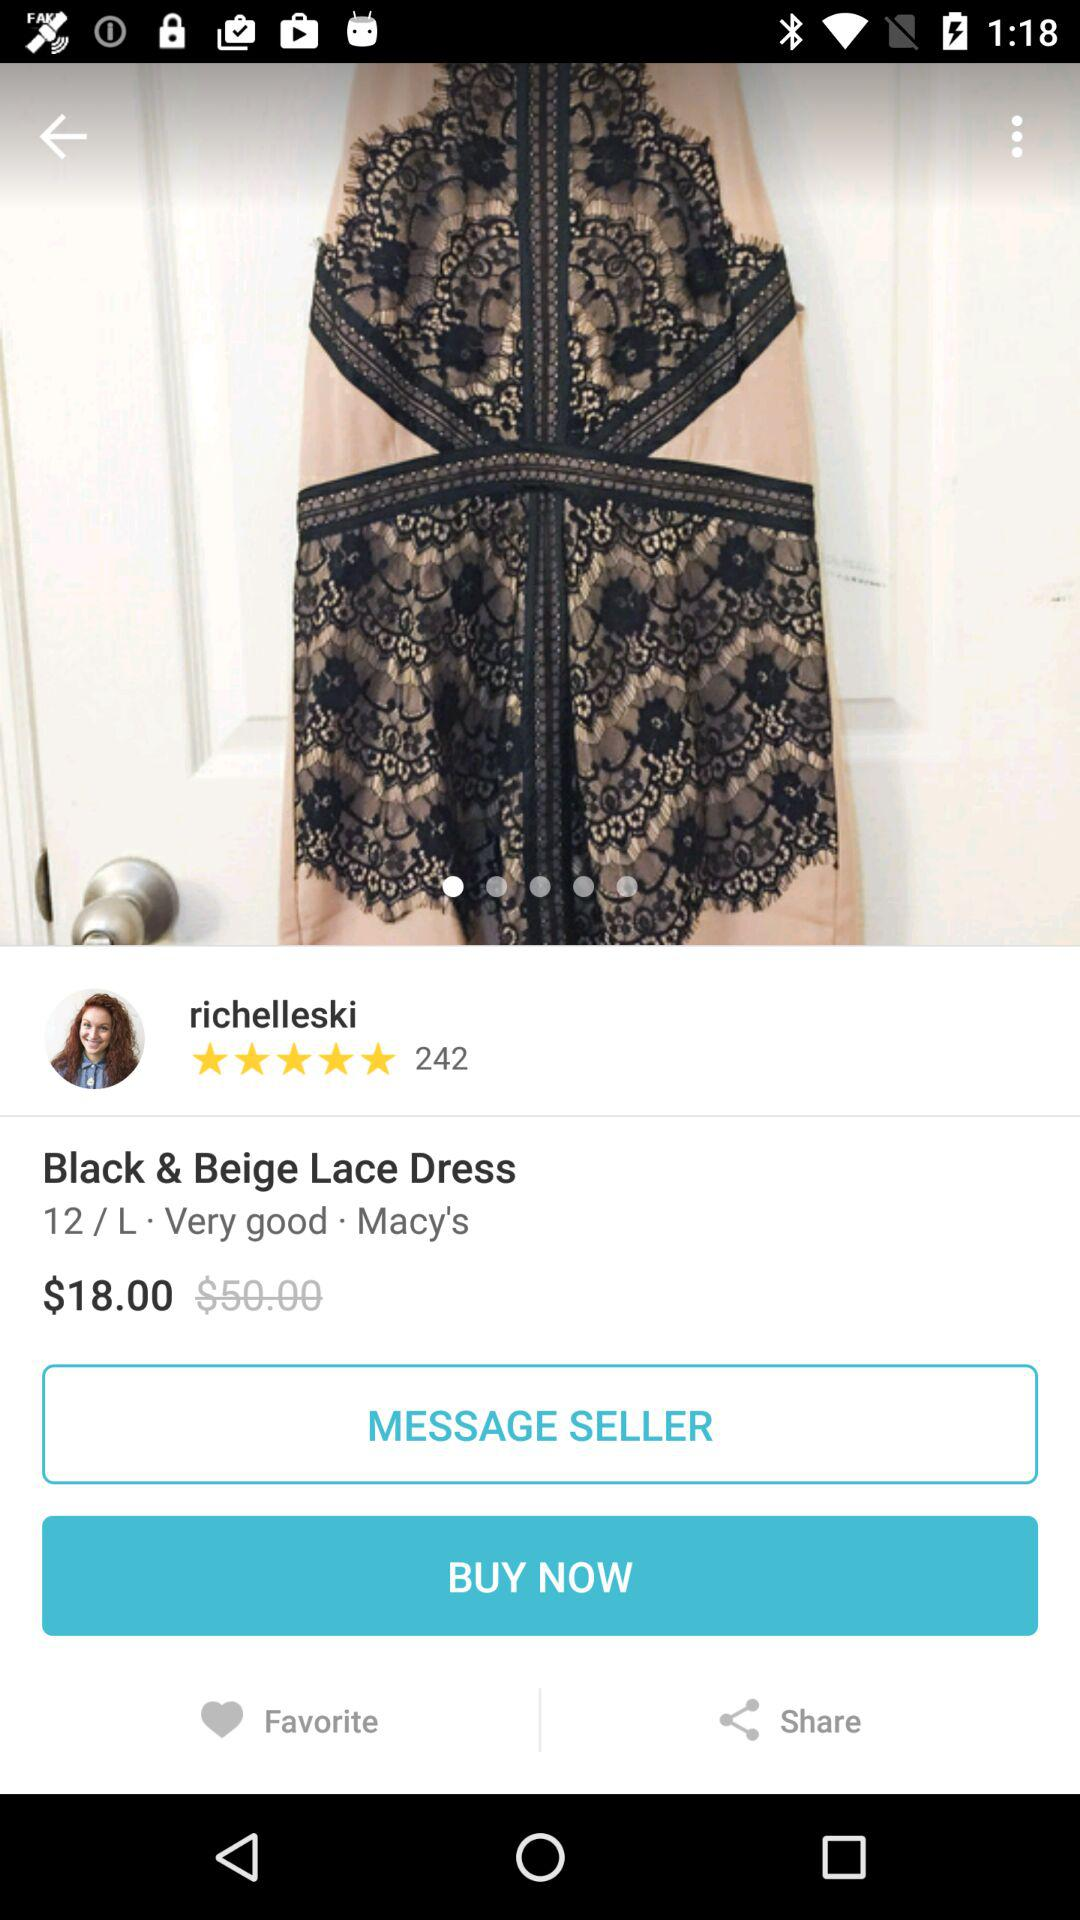What is the cost of the dress? The cost is $18.00. 